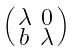<formula> <loc_0><loc_0><loc_500><loc_500>\begin{psmallmatrix} \lambda & 0 \\ b & \lambda \end{psmallmatrix}</formula> 